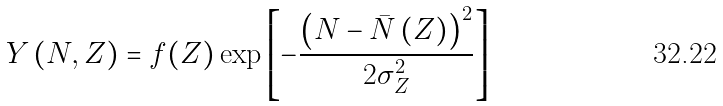Convert formula to latex. <formula><loc_0><loc_0><loc_500><loc_500>Y \left ( N , Z \right ) = f ( Z ) \exp \left [ - \frac { \left ( N - \bar { N } \left ( Z \right ) \right ) ^ { 2 } } { 2 \sigma _ { Z } ^ { 2 } } \right ]</formula> 